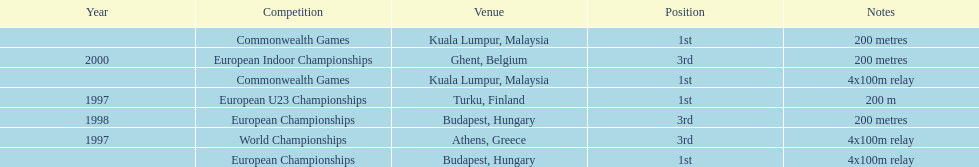How many total years did golding compete? 3. 